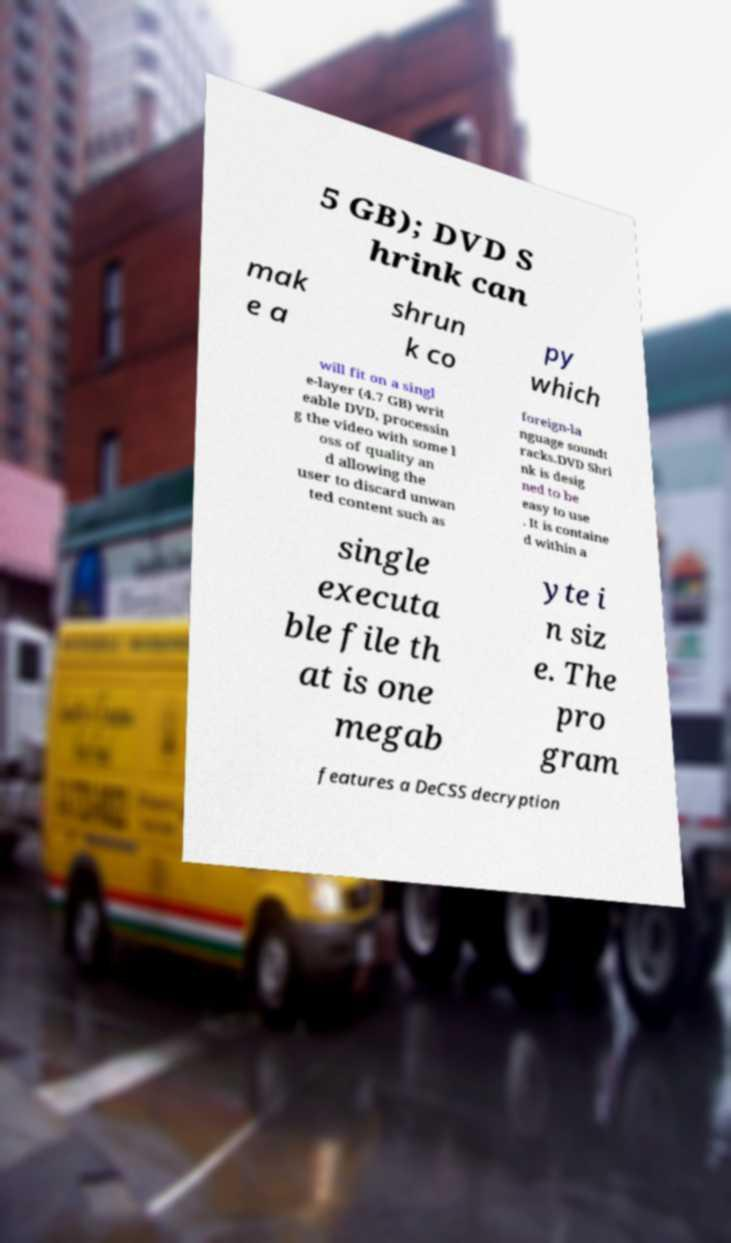There's text embedded in this image that I need extracted. Can you transcribe it verbatim? 5 GB); DVD S hrink can mak e a shrun k co py which will fit on a singl e-layer (4.7 GB) writ eable DVD, processin g the video with some l oss of quality an d allowing the user to discard unwan ted content such as foreign-la nguage soundt racks.DVD Shri nk is desig ned to be easy to use . It is containe d within a single executa ble file th at is one megab yte i n siz e. The pro gram features a DeCSS decryption 